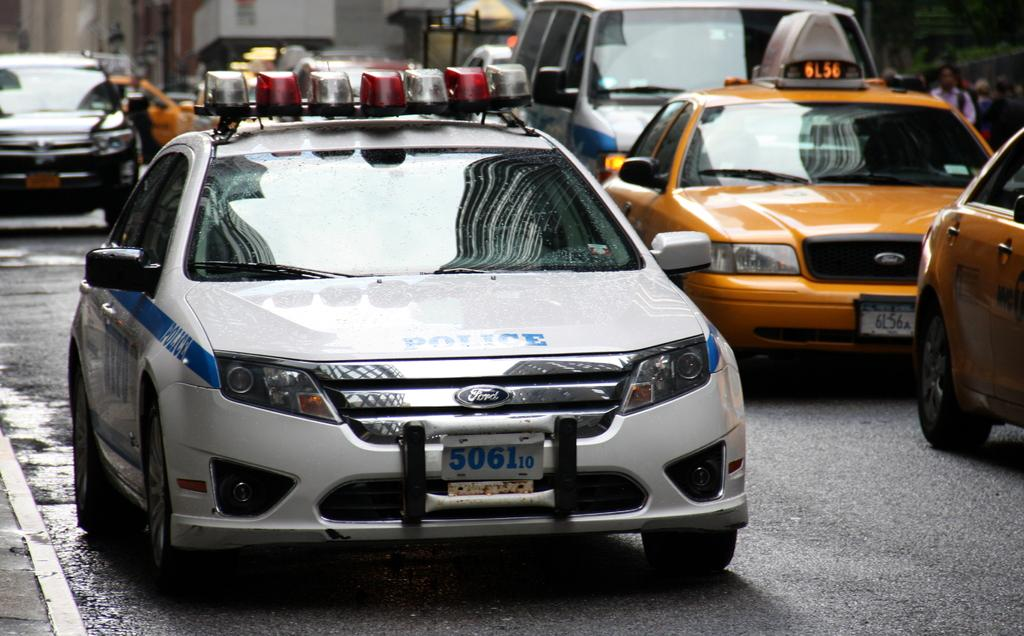What can be observed about the background of the image? The background portion of the picture is blurred. What is happening in the foreground of the image? There are vehicles on the road in the image. Are there any people visible in the image? Yes, there are people visible on the right side of the image. What is the faraway object visible in the image? An umbrella is visible far away in the image. What type of space division can be seen in the image? There is no mention of any space division in the image, as it primarily features vehicles, people, and an umbrella. 